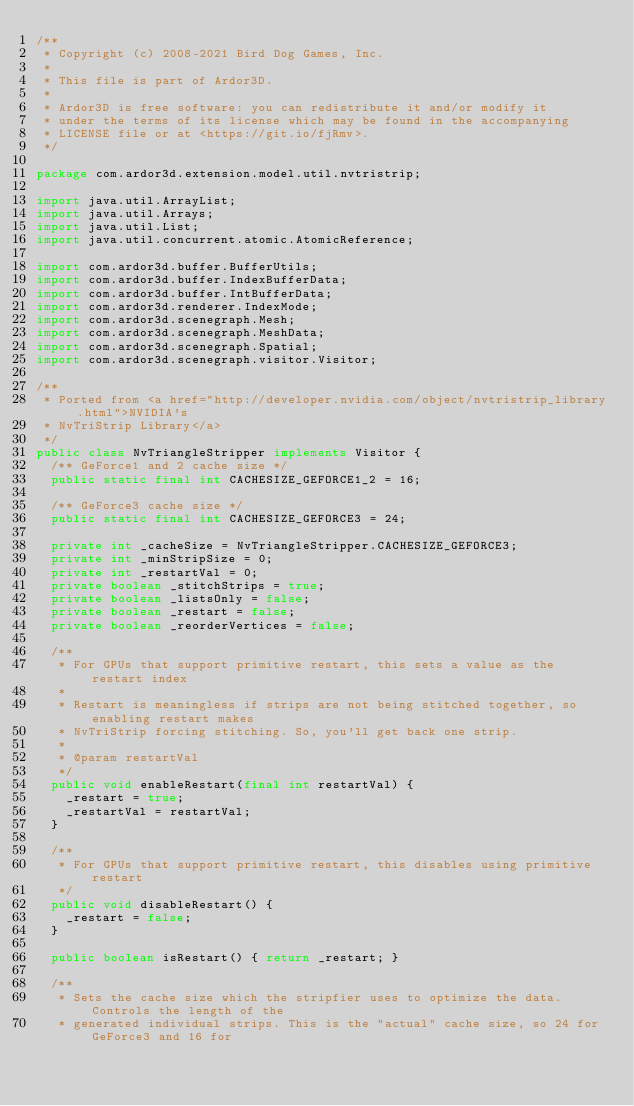Convert code to text. <code><loc_0><loc_0><loc_500><loc_500><_Java_>/**
 * Copyright (c) 2008-2021 Bird Dog Games, Inc.
 *
 * This file is part of Ardor3D.
 *
 * Ardor3D is free software: you can redistribute it and/or modify it
 * under the terms of its license which may be found in the accompanying
 * LICENSE file or at <https://git.io/fjRmv>.
 */

package com.ardor3d.extension.model.util.nvtristrip;

import java.util.ArrayList;
import java.util.Arrays;
import java.util.List;
import java.util.concurrent.atomic.AtomicReference;

import com.ardor3d.buffer.BufferUtils;
import com.ardor3d.buffer.IndexBufferData;
import com.ardor3d.buffer.IntBufferData;
import com.ardor3d.renderer.IndexMode;
import com.ardor3d.scenegraph.Mesh;
import com.ardor3d.scenegraph.MeshData;
import com.ardor3d.scenegraph.Spatial;
import com.ardor3d.scenegraph.visitor.Visitor;

/**
 * Ported from <a href="http://developer.nvidia.com/object/nvtristrip_library.html">NVIDIA's
 * NvTriStrip Library</a>
 */
public class NvTriangleStripper implements Visitor {
  /** GeForce1 and 2 cache size */
  public static final int CACHESIZE_GEFORCE1_2 = 16;

  /** GeForce3 cache size */
  public static final int CACHESIZE_GEFORCE3 = 24;

  private int _cacheSize = NvTriangleStripper.CACHESIZE_GEFORCE3;
  private int _minStripSize = 0;
  private int _restartVal = 0;
  private boolean _stitchStrips = true;
  private boolean _listsOnly = false;
  private boolean _restart = false;
  private boolean _reorderVertices = false;

  /**
   * For GPUs that support primitive restart, this sets a value as the restart index
   * 
   * Restart is meaningless if strips are not being stitched together, so enabling restart makes
   * NvTriStrip forcing stitching. So, you'll get back one strip.
   * 
   * @param restartVal
   */
  public void enableRestart(final int restartVal) {
    _restart = true;
    _restartVal = restartVal;
  }

  /**
   * For GPUs that support primitive restart, this disables using primitive restart
   */
  public void disableRestart() {
    _restart = false;
  }

  public boolean isRestart() { return _restart; }

  /**
   * Sets the cache size which the stripfier uses to optimize the data. Controls the length of the
   * generated individual strips. This is the "actual" cache size, so 24 for GeForce3 and 16 for</code> 